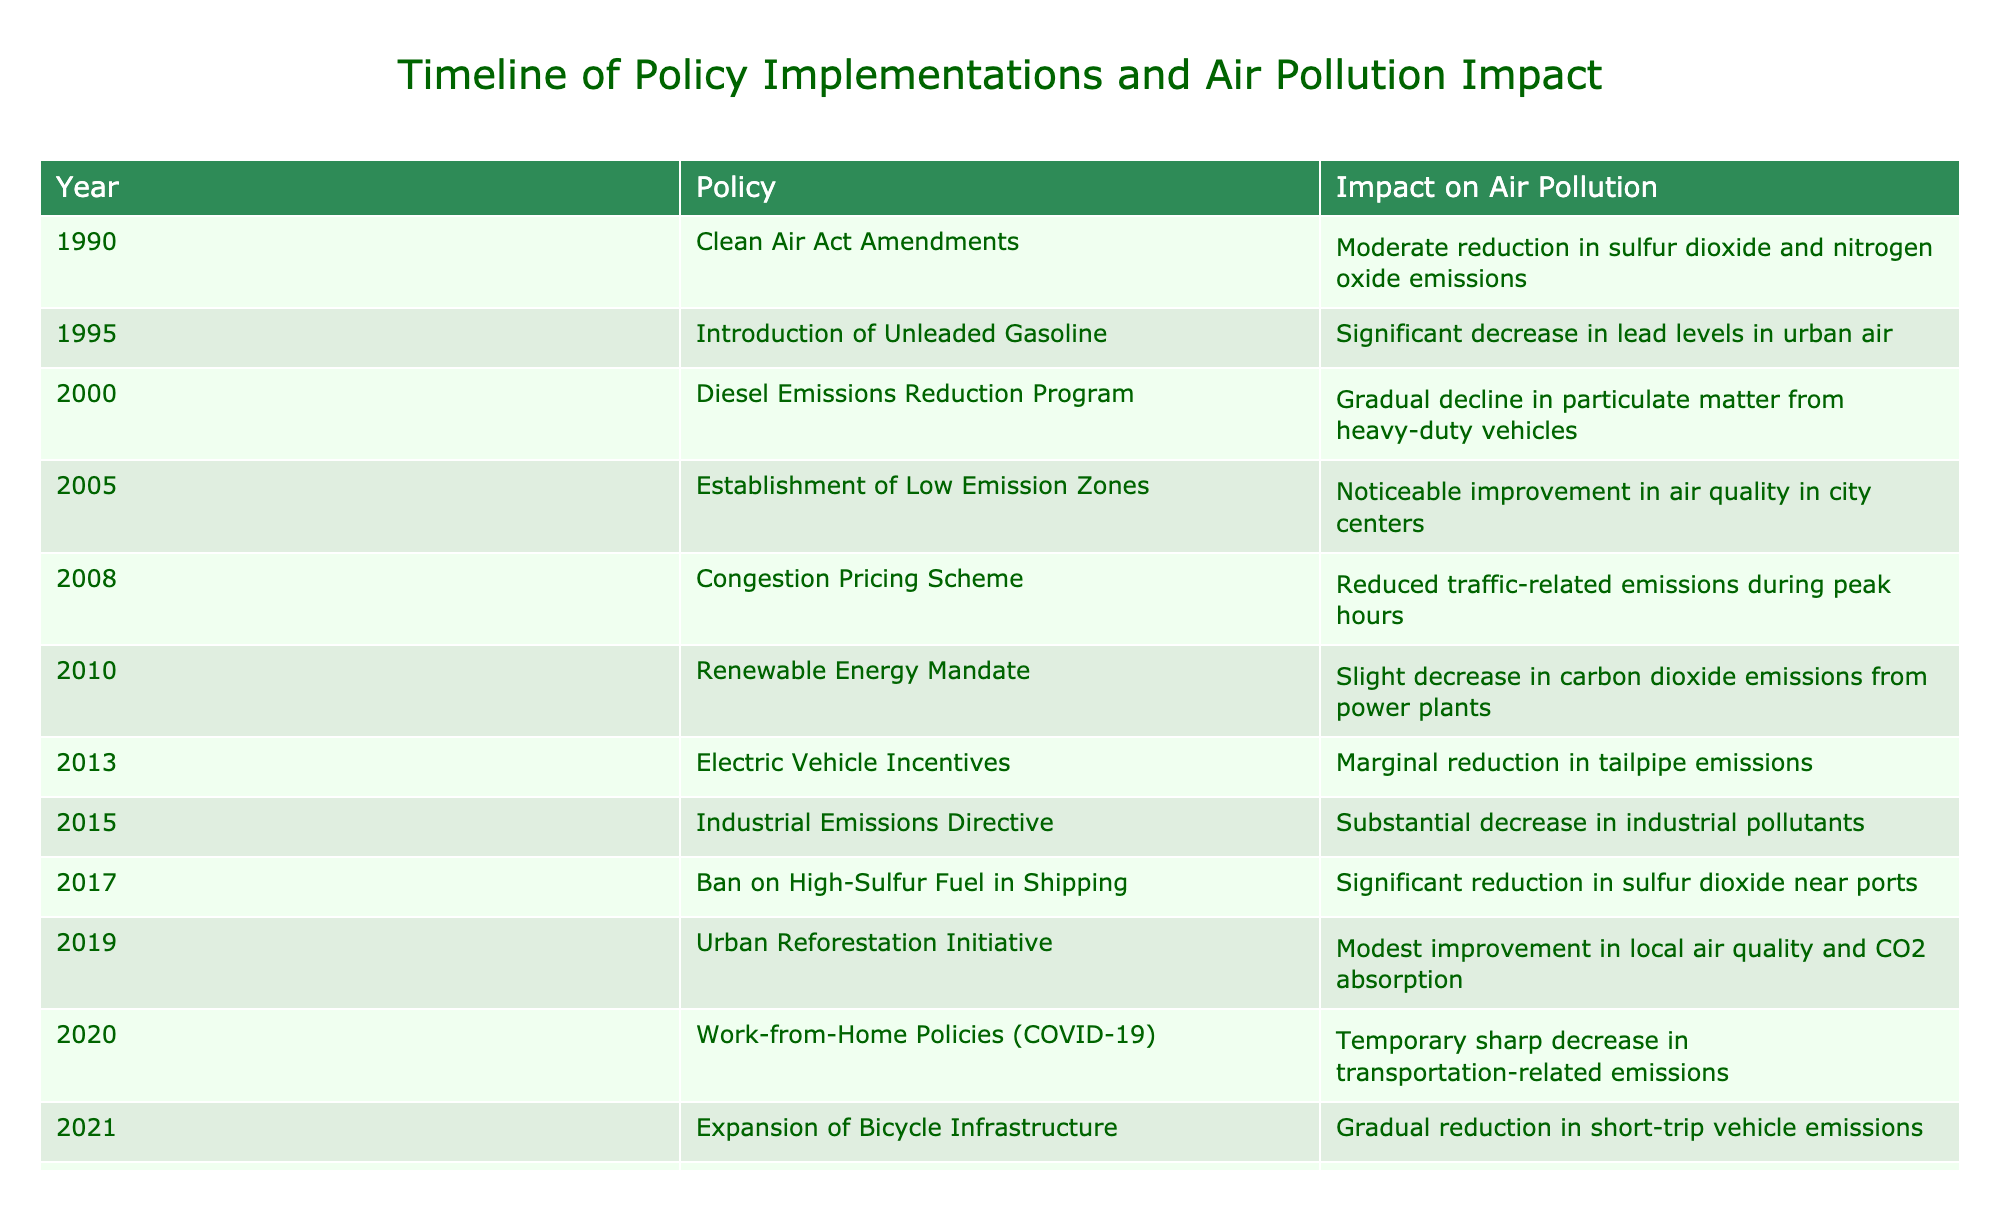What was the impact of the Clean Air Act Amendments implemented in 1990? The table states that the Clean Air Act Amendments resulted in a "Moderate reduction in sulfur dioxide and nitrogen oxide emissions." This directly refers to the specific impact described in the row for the year 1990.
Answer: Moderate reduction in sulfur dioxide and nitrogen oxide emissions Which policy had the most significant impact on air pollution and what was its effect? According to the table, the Industrial Emissions Directive implemented in 2015 led to a "Substantial decrease in industrial pollutants," indicating it had the most significant impact on air pollution among the listed policies.
Answer: Substantial decrease in industrial pollutants Did the Urban Reforestation Initiative in 2019 improve air quality? The entry for the Urban Reforestation Initiative in the table indicates a "Modest improvement in local air quality and CO2 absorption," which suggests that the initiative did lead to an improvement in air quality.
Answer: Yes What is the average impact of all policies on particulate matter reduction? There are three policies related to particulate matter reduction: the Diesel Emissions Reduction Program (gradual decline), the Establishment of Low Emission Zones (noticeable improvement), and the Industrial Emissions Directive (substantial decrease). While these are qualitative impacts and not numerical values, we can categorize them in a scale, with "gradual decline" least effective and "substantial decrease" most effective. By considering the qualitative scale as: gradual < noticeable < substantial, the average could be considered around "moderate" on this qualitative scale.
Answer: Moderate Which policies resulted in a decrease in carbon dioxide emissions? Looking at the table, the Renewable Energy Mandate in 2010 shows a "Slight decrease in carbon dioxide emissions from power plants," and the Urban Reforestation Initiative in 2019 has "Modest improvement in local air quality and CO2 absorption." Therefore, these two policies resulted in decreases in carbon dioxide emissions.
Answer: Renewable Energy Mandate and Urban Reforestation Initiative What was the combined effect of policies implemented from 2010 to 2022? The policies during this period include the Renewable Energy Mandate, Electric Vehicle Incentives, Industrial Emissions Directive, Ban on High-Sulfur Fuel in Shipping, Urban Reforestation Initiative, Work-from-Home Policies, Expansion of Bicycle Infrastructure, and Smart Traffic Management. Collectively, these policies indicate a trend toward reducing emissions (from slight to substantial) and improving air quality. However, to quantify it exactly would not be feasible as the effects are qualitative rather than quantitative. So, the overall combined effect is interpreted as a significant improvement in air quality over time with varying levels of impact.
Answer: Significant improvement in air quality Was the Congestion Pricing Scheme effective in reducing air pollution, and how so? The Congestion Pricing Scheme from 2008 led to "Reduced traffic-related emissions during peak hours," which suggests it was effective in reducing air pollution specifically linked to traffic during busy times. The effectiveness can be inferred directly from the impact described in the table.
Answer: Yes, it reduced traffic-related emissions during peak hours 